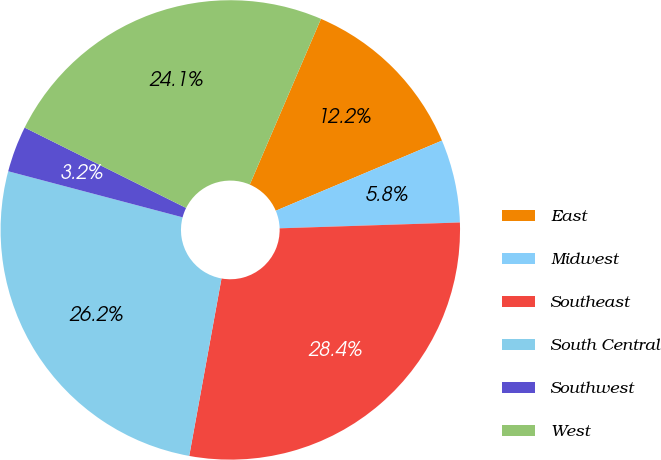<chart> <loc_0><loc_0><loc_500><loc_500><pie_chart><fcel>East<fcel>Midwest<fcel>Southeast<fcel>South Central<fcel>Southwest<fcel>West<nl><fcel>12.19%<fcel>5.84%<fcel>28.38%<fcel>26.25%<fcel>3.24%<fcel>24.11%<nl></chart> 